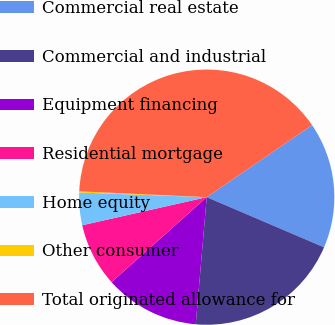<chart> <loc_0><loc_0><loc_500><loc_500><pie_chart><fcel>Commercial real estate<fcel>Commercial and industrial<fcel>Equipment financing<fcel>Residential mortgage<fcel>Home equity<fcel>Other consumer<fcel>Total originated allowance for<nl><fcel>15.98%<fcel>19.94%<fcel>12.02%<fcel>8.07%<fcel>4.11%<fcel>0.15%<fcel>39.72%<nl></chart> 